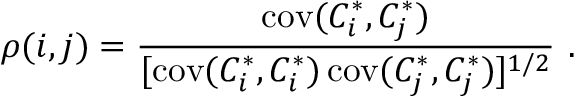<formula> <loc_0><loc_0><loc_500><loc_500>\rho ( i , j ) = \frac { c o v ( C _ { i } ^ { * } , C _ { j } ^ { * } ) } { [ c o v ( C _ { i } ^ { * } , C _ { i } ^ { * } ) \, c o v ( C _ { j } ^ { * } , C _ { j } ^ { * } ) ] ^ { 1 / 2 } } .</formula> 